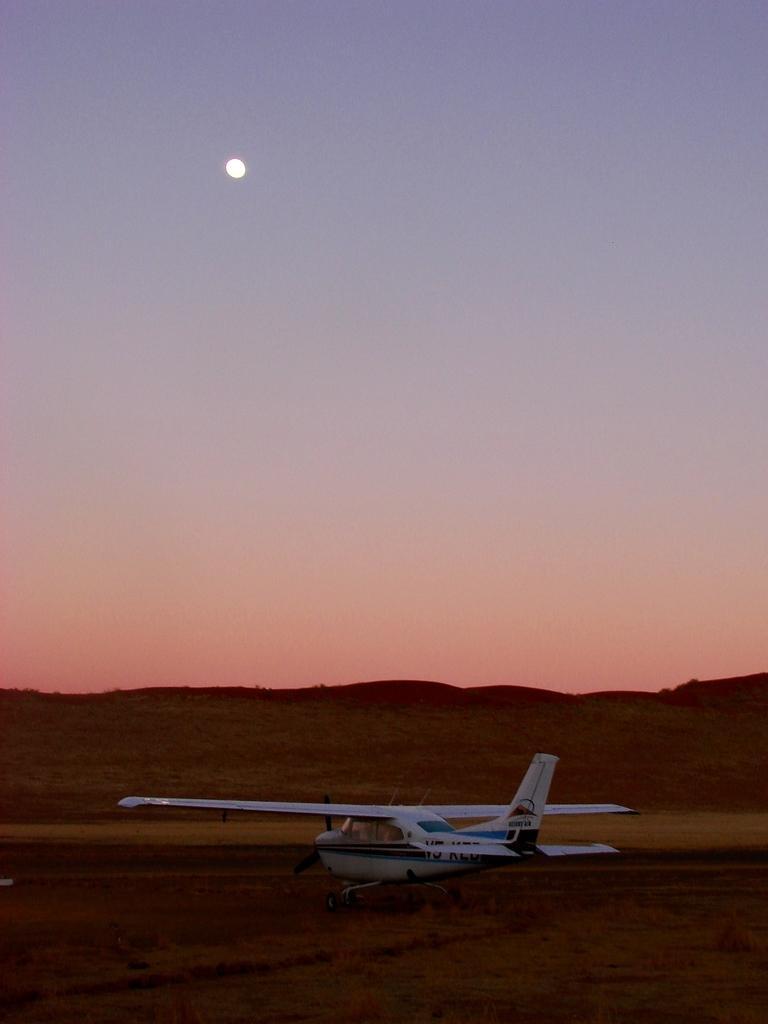How would you summarize this image in a sentence or two? In the foreground of the image we can see the helicopter. In the middle of the image we can see the structure like hills. On the top of the image we can see the sky and the sun. 